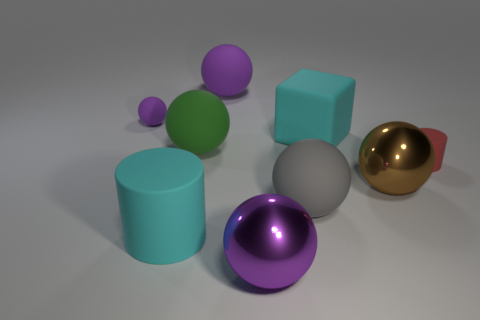Subtract all purple spheres. How many were subtracted if there are1purple spheres left? 2 Subtract all brown cubes. How many purple balls are left? 3 Subtract 3 spheres. How many spheres are left? 3 Subtract all large gray matte balls. How many balls are left? 5 Subtract all brown spheres. How many spheres are left? 5 Subtract all brown balls. Subtract all purple blocks. How many balls are left? 5 Add 1 red metal blocks. How many objects exist? 10 Subtract all cubes. How many objects are left? 8 Add 7 purple rubber spheres. How many purple rubber spheres exist? 9 Subtract 0 yellow blocks. How many objects are left? 9 